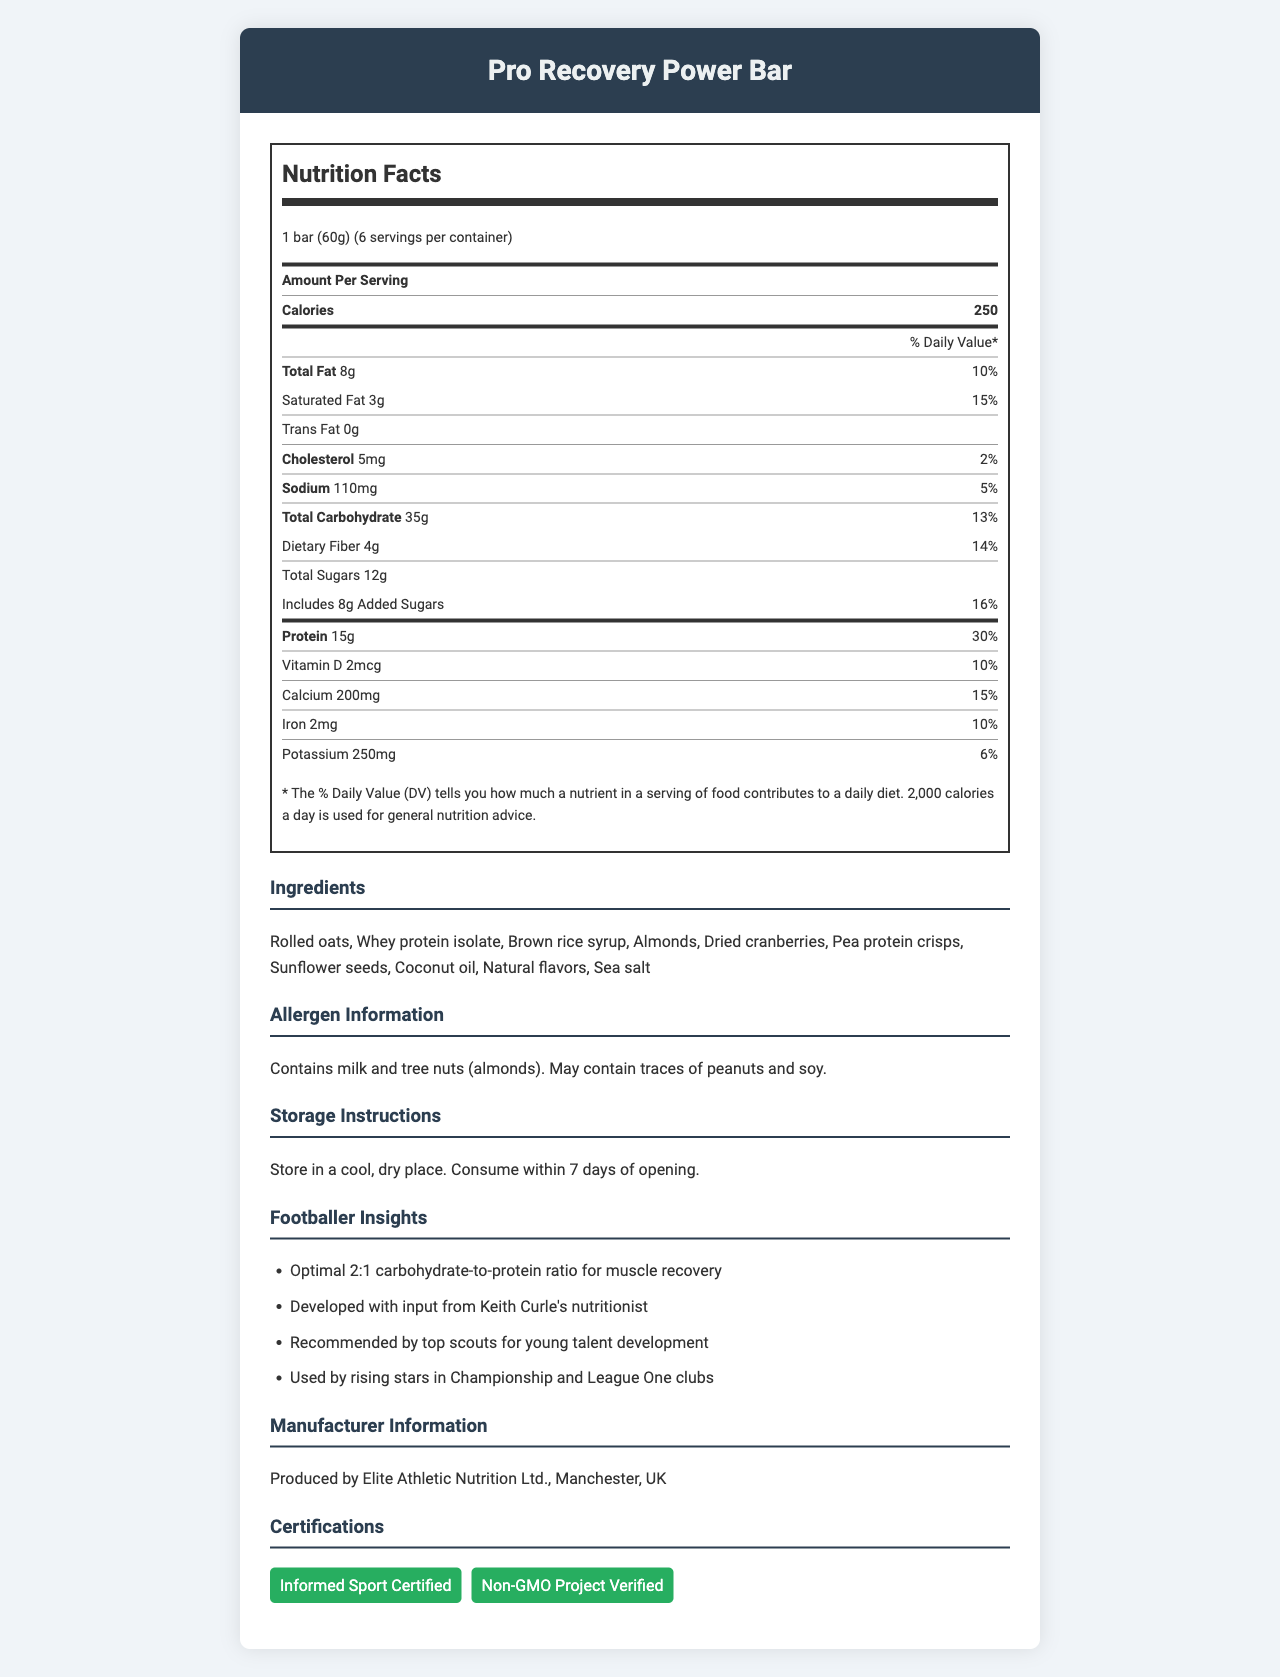what is the serving size of the Pro Recovery Power Bar? The serving size is listed at the top of the document under the product name.
Answer: 1 bar (60g) how many calories are there per serving? The calories per serving are given in the nutrition facts section under "Amount Per Serving".
Answer: 250 calories what percentage of the daily value is the protein content per serving? The protein content and its daily value percentage are listed in the nutrition facts under the protein section.
Answer: 30% what are the main ingredients in the Pro Recovery Power Bar? The ingredients are detailed in the ingredients section of the document.
Answer: Rolled oats, Whey protein isolate, Brown rice syrup, Almonds, Dried cranberries, Pea protein crisps, Sunflower seeds, Coconut oil, Natural flavors, Sea salt. how much total fat is there per serving? The total fat content per serving is listed in the nutrition facts section.
Answer: 8g which vitamin is included with a daily value percentage of 10%? The nutrition facts indicate that Vitamin D has a daily value percentage of 10%.
Answer: Vitamin D how much dietary fiber is included per serving? The dietary fiber per serving is found in the nutrition facts under total carbohydrate.
Answer: 4g what is the ratio of carbohydrate to protein in the Pro Recovery Power Bar? A. 1:1 B. 2:1 C. 3:1 D. 1:2 The total carbohydrates are 35g and the protein is 15g, giving a ratio of approximately 2:1.
Answer: B. 2:1 which of the following is not listed as an ingredient in the Pro Recovery Power Bar? A. Almonds B. Pea protein crisps C. Peanut butter D. Brown rice syrup The list of ingredients does not include peanut butter.
Answer: C. Peanut butter does the Pro Recovery Power Bar contain any trans fat? The nutrition facts section states that the trans fat content is 0g.
Answer: No is the Pro Recovery Power Bar suggested for consumption before or after training? The footballer insights indicate that it is optimal for muscle recovery, which suggests post-training consumption.
Answer: After what certifications does the Pro Recovery Power Bar hold? The certifications section lists these two certifications.
Answer: Informed Sport Certified, Non-GMO Project Verified what storage instructions are given for the Pro Recovery Power Bar? The storage instructions provide details on how to store the product and its consumption timeline after opening.
Answer: Store in a cool, dry place. Consume within 7 days of opening. who developed the Pro Recovery Power Bar with input from a nutritionist? The footballer insights mention that the product was developed with input from Keith Curle's nutritionist.
Answer: Keith Curle which nutrient has the lowest daily value percentage per serving? A. Vitamin D B. Calcium C. Iron D. Cholesterol The daily value percentage for cholesterol is 2%, which is the lowest compared to Vitamin D, Calcium, and Iron.
Answer: D. Cholesterol describe the main idea of the document. The document focuses on the nutritional value and benefits of the Pro Recovery Power Bar, including its ingredients, certifications, and suitability for post-training muscle recovery.
Answer: The document provides detailed information about the Pro Recovery Power Bar, including serving size, nutritional content, ingredients, allergen information, storage instructions, footballer insights, manufacturer information, and certifications. what is the exact manufacturing address of Elite Athletic Nutrition Ltd.? The document only mentions Manchester, UK, but does not provide an exact address.
Answer: Not enough information 